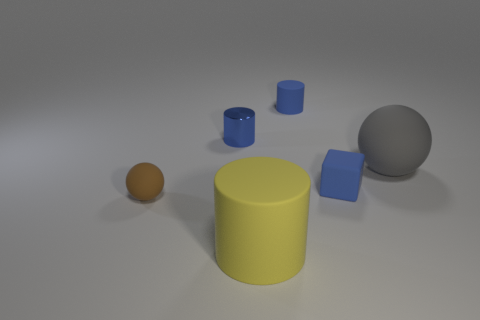Subtract all matte cylinders. How many cylinders are left? 1 Add 4 brown balls. How many objects exist? 10 Subtract all cubes. How many objects are left? 5 Subtract all yellow cubes. How many blue cylinders are left? 2 Subtract 1 cylinders. How many cylinders are left? 2 Subtract all blue cylinders. How many cylinders are left? 1 Add 4 small blue matte objects. How many small blue matte objects are left? 6 Add 5 small rubber cylinders. How many small rubber cylinders exist? 6 Subtract 0 cyan balls. How many objects are left? 6 Subtract all green balls. Subtract all red cylinders. How many balls are left? 2 